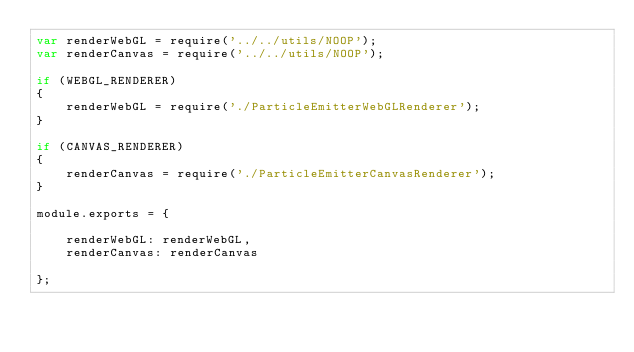<code> <loc_0><loc_0><loc_500><loc_500><_JavaScript_>var renderWebGL = require('../../utils/NOOP');
var renderCanvas = require('../../utils/NOOP');

if (WEBGL_RENDERER)
{
    renderWebGL = require('./ParticleEmitterWebGLRenderer');
}

if (CANVAS_RENDERER)
{
    renderCanvas = require('./ParticleEmitterCanvasRenderer');
}

module.exports = {

    renderWebGL: renderWebGL,
    renderCanvas: renderCanvas

};
</code> 